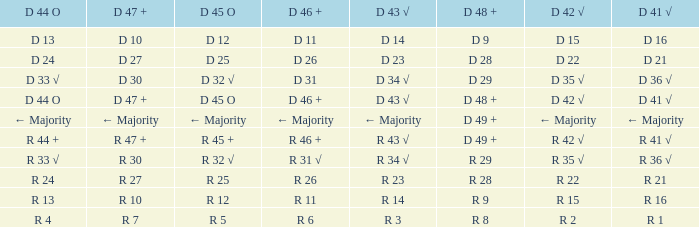What is the value of D 45 O, when the value of D 41 √ is r 41 √? R 45 +. 